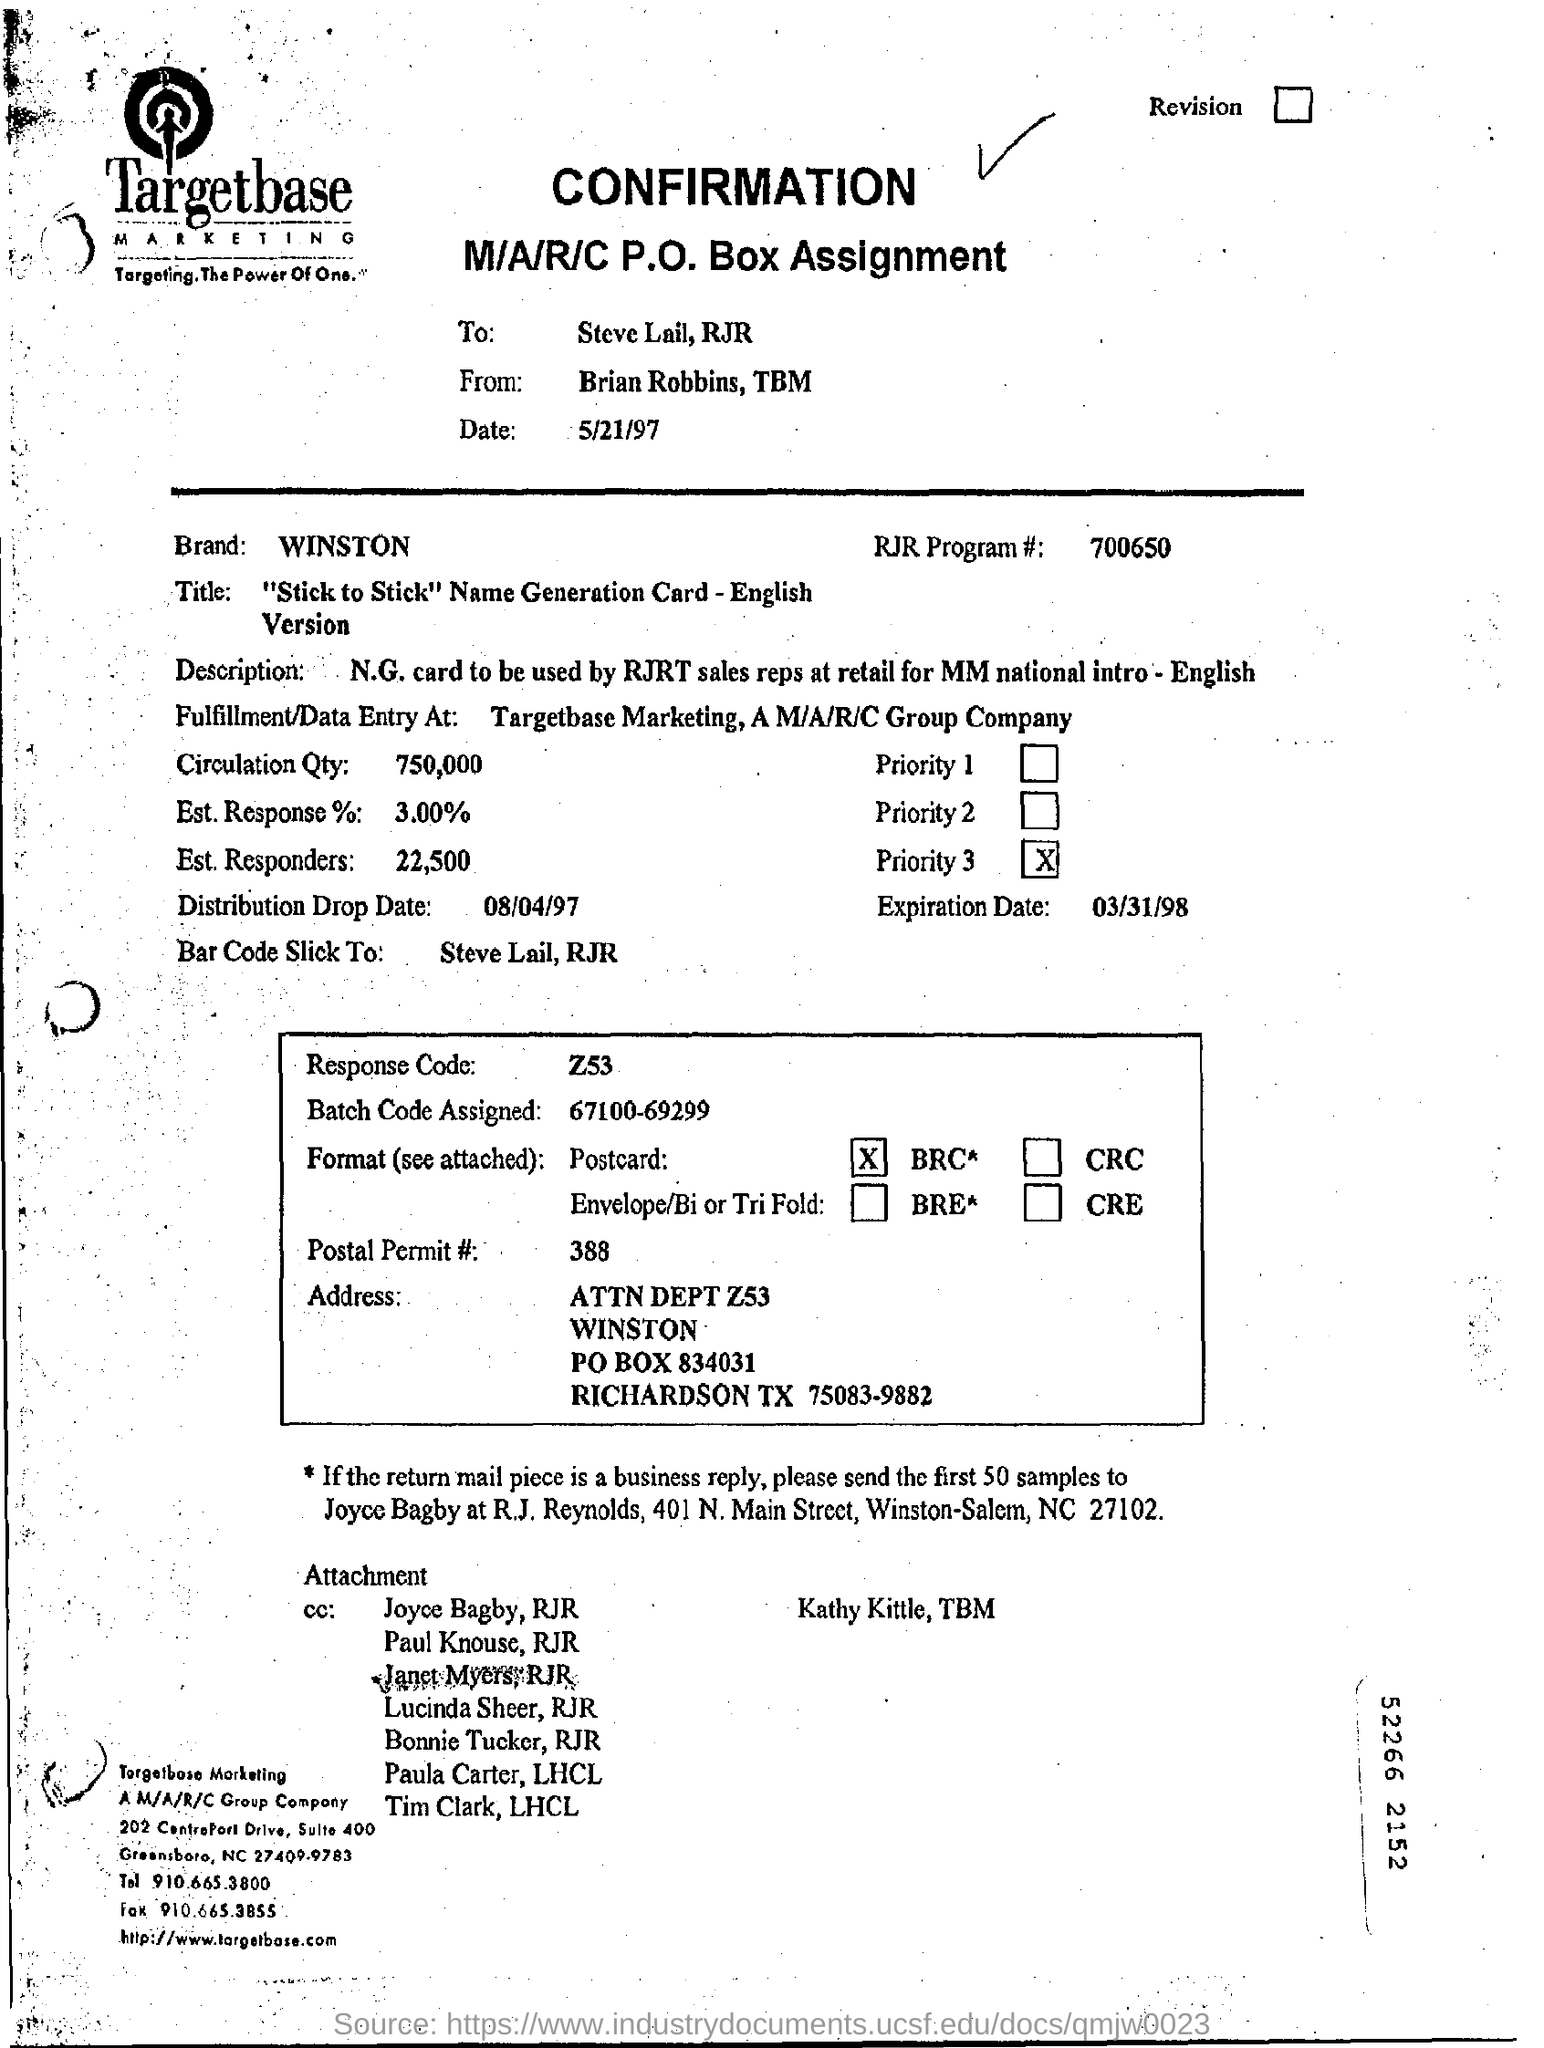What is the number of the rjr program?
Offer a very short reply. 700650. Where is the fulfilment/data entry at?
Give a very brief answer. Targetbase Marketing, A M/A/R//C Group Company. What is the distribution drop date?
Your answer should be very brief. 08/04/97. What is the postal permit number# ?
Offer a very short reply. 388. 